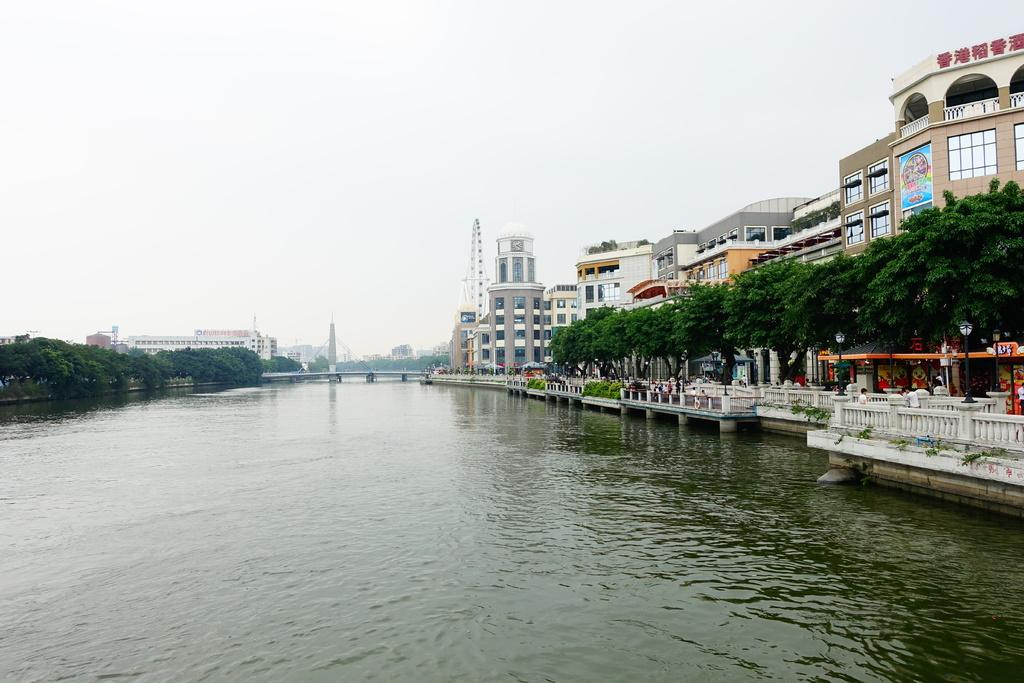What type of natural feature is present in the image? There is a river in the image. What structure is located in front of the river? There is a bridge in front of the river. What type of vegetation is present on either side of the river? There are trees on either side of the river. What type of man-made structures are present on either side of the river? There are buildings on either side of the river. How many bears can be seen working on the bridge in the image? There are no bears present in the image, and therefore no bears can be seen working on the bridge. 